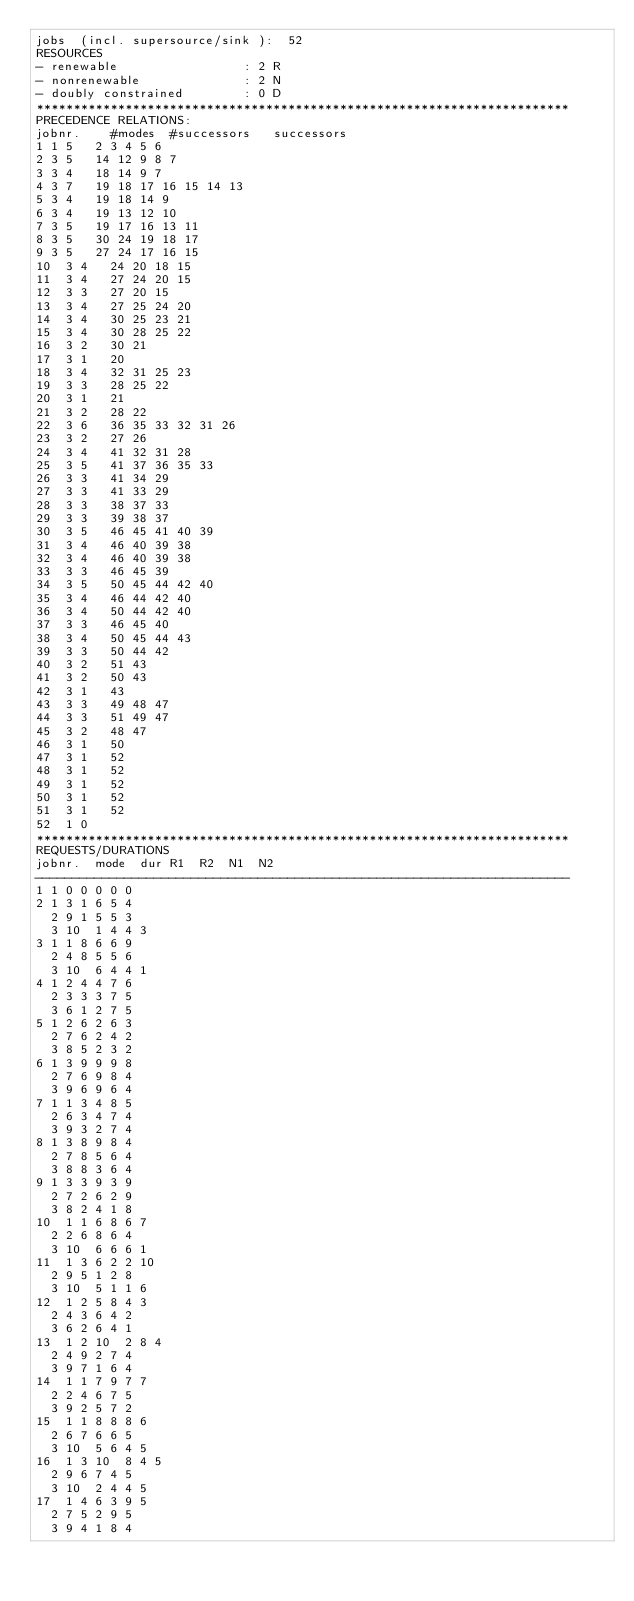<code> <loc_0><loc_0><loc_500><loc_500><_ObjectiveC_>jobs  (incl. supersource/sink ):	52
RESOURCES
- renewable                 : 2 R
- nonrenewable              : 2 N
- doubly constrained        : 0 D
************************************************************************
PRECEDENCE RELATIONS:
jobnr.    #modes  #successors   successors
1	1	5		2 3 4 5 6 
2	3	5		14 12 9 8 7 
3	3	4		18 14 9 7 
4	3	7		19 18 17 16 15 14 13 
5	3	4		19 18 14 9 
6	3	4		19 13 12 10 
7	3	5		19 17 16 13 11 
8	3	5		30 24 19 18 17 
9	3	5		27 24 17 16 15 
10	3	4		24 20 18 15 
11	3	4		27 24 20 15 
12	3	3		27 20 15 
13	3	4		27 25 24 20 
14	3	4		30 25 23 21 
15	3	4		30 28 25 22 
16	3	2		30 21 
17	3	1		20 
18	3	4		32 31 25 23 
19	3	3		28 25 22 
20	3	1		21 
21	3	2		28 22 
22	3	6		36 35 33 32 31 26 
23	3	2		27 26 
24	3	4		41 32 31 28 
25	3	5		41 37 36 35 33 
26	3	3		41 34 29 
27	3	3		41 33 29 
28	3	3		38 37 33 
29	3	3		39 38 37 
30	3	5		46 45 41 40 39 
31	3	4		46 40 39 38 
32	3	4		46 40 39 38 
33	3	3		46 45 39 
34	3	5		50 45 44 42 40 
35	3	4		46 44 42 40 
36	3	4		50 44 42 40 
37	3	3		46 45 40 
38	3	4		50 45 44 43 
39	3	3		50 44 42 
40	3	2		51 43 
41	3	2		50 43 
42	3	1		43 
43	3	3		49 48 47 
44	3	3		51 49 47 
45	3	2		48 47 
46	3	1		50 
47	3	1		52 
48	3	1		52 
49	3	1		52 
50	3	1		52 
51	3	1		52 
52	1	0		
************************************************************************
REQUESTS/DURATIONS
jobnr.	mode	dur	R1	R2	N1	N2	
------------------------------------------------------------------------
1	1	0	0	0	0	0	
2	1	3	1	6	5	4	
	2	9	1	5	5	3	
	3	10	1	4	4	3	
3	1	1	8	6	6	9	
	2	4	8	5	5	6	
	3	10	6	4	4	1	
4	1	2	4	4	7	6	
	2	3	3	3	7	5	
	3	6	1	2	7	5	
5	1	2	6	2	6	3	
	2	7	6	2	4	2	
	3	8	5	2	3	2	
6	1	3	9	9	9	8	
	2	7	6	9	8	4	
	3	9	6	9	6	4	
7	1	1	3	4	8	5	
	2	6	3	4	7	4	
	3	9	3	2	7	4	
8	1	3	8	9	8	4	
	2	7	8	5	6	4	
	3	8	8	3	6	4	
9	1	3	3	9	3	9	
	2	7	2	6	2	9	
	3	8	2	4	1	8	
10	1	1	6	8	6	7	
	2	2	6	8	6	4	
	3	10	6	6	6	1	
11	1	3	6	2	2	10	
	2	9	5	1	2	8	
	3	10	5	1	1	6	
12	1	2	5	8	4	3	
	2	4	3	6	4	2	
	3	6	2	6	4	1	
13	1	2	10	2	8	4	
	2	4	9	2	7	4	
	3	9	7	1	6	4	
14	1	1	7	9	7	7	
	2	2	4	6	7	5	
	3	9	2	5	7	2	
15	1	1	8	8	8	6	
	2	6	7	6	6	5	
	3	10	5	6	4	5	
16	1	3	10	8	4	5	
	2	9	6	7	4	5	
	3	10	2	4	4	5	
17	1	4	6	3	9	5	
	2	7	5	2	9	5	
	3	9	4	1	8	4	</code> 